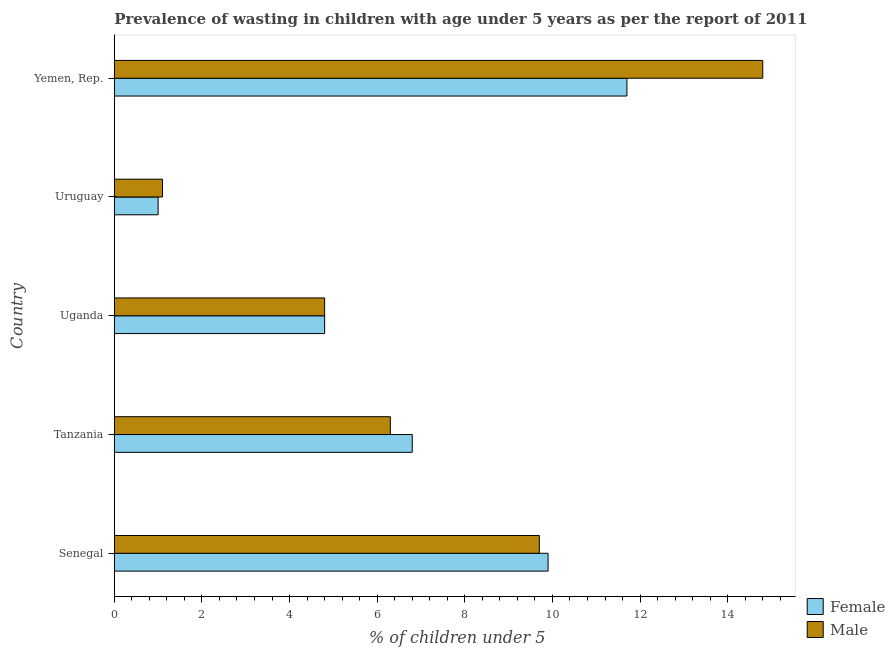How many different coloured bars are there?
Your response must be concise. 2. What is the label of the 3rd group of bars from the top?
Your response must be concise. Uganda. In how many cases, is the number of bars for a given country not equal to the number of legend labels?
Provide a short and direct response. 0. What is the percentage of undernourished female children in Yemen, Rep.?
Offer a terse response. 11.7. Across all countries, what is the maximum percentage of undernourished male children?
Make the answer very short. 14.8. Across all countries, what is the minimum percentage of undernourished male children?
Provide a short and direct response. 1.1. In which country was the percentage of undernourished male children maximum?
Give a very brief answer. Yemen, Rep. In which country was the percentage of undernourished male children minimum?
Keep it short and to the point. Uruguay. What is the total percentage of undernourished female children in the graph?
Offer a very short reply. 34.2. What is the difference between the percentage of undernourished male children in Yemen, Rep. and the percentage of undernourished female children in Uruguay?
Your answer should be very brief. 13.8. What is the average percentage of undernourished male children per country?
Your response must be concise. 7.34. In how many countries, is the percentage of undernourished male children greater than 6.8 %?
Offer a very short reply. 2. What is the ratio of the percentage of undernourished female children in Senegal to that in Uganda?
Ensure brevity in your answer.  2.06. What is the difference between the highest and the second highest percentage of undernourished male children?
Make the answer very short. 5.1. What is the difference between the highest and the lowest percentage of undernourished female children?
Give a very brief answer. 10.7. Is the sum of the percentage of undernourished female children in Uruguay and Yemen, Rep. greater than the maximum percentage of undernourished male children across all countries?
Provide a succinct answer. No. What does the 2nd bar from the top in Senegal represents?
Give a very brief answer. Female. What does the 2nd bar from the bottom in Uganda represents?
Ensure brevity in your answer.  Male. How many legend labels are there?
Offer a terse response. 2. What is the title of the graph?
Keep it short and to the point. Prevalence of wasting in children with age under 5 years as per the report of 2011. Does "Private consumption" appear as one of the legend labels in the graph?
Give a very brief answer. No. What is the label or title of the X-axis?
Keep it short and to the point.  % of children under 5. What is the label or title of the Y-axis?
Provide a short and direct response. Country. What is the  % of children under 5 of Female in Senegal?
Keep it short and to the point. 9.9. What is the  % of children under 5 of Male in Senegal?
Offer a very short reply. 9.7. What is the  % of children under 5 of Female in Tanzania?
Your answer should be compact. 6.8. What is the  % of children under 5 in Male in Tanzania?
Offer a terse response. 6.3. What is the  % of children under 5 of Female in Uganda?
Your answer should be compact. 4.8. What is the  % of children under 5 of Male in Uganda?
Your answer should be very brief. 4.8. What is the  % of children under 5 of Female in Uruguay?
Give a very brief answer. 1. What is the  % of children under 5 in Male in Uruguay?
Provide a succinct answer. 1.1. What is the  % of children under 5 of Female in Yemen, Rep.?
Ensure brevity in your answer.  11.7. What is the  % of children under 5 in Male in Yemen, Rep.?
Ensure brevity in your answer.  14.8. Across all countries, what is the maximum  % of children under 5 of Female?
Your answer should be compact. 11.7. Across all countries, what is the maximum  % of children under 5 in Male?
Offer a terse response. 14.8. Across all countries, what is the minimum  % of children under 5 in Male?
Your answer should be very brief. 1.1. What is the total  % of children under 5 in Female in the graph?
Provide a short and direct response. 34.2. What is the total  % of children under 5 of Male in the graph?
Ensure brevity in your answer.  36.7. What is the difference between the  % of children under 5 in Female in Senegal and that in Uganda?
Keep it short and to the point. 5.1. What is the difference between the  % of children under 5 of Male in Senegal and that in Uruguay?
Give a very brief answer. 8.6. What is the difference between the  % of children under 5 of Female in Senegal and that in Yemen, Rep.?
Provide a short and direct response. -1.8. What is the difference between the  % of children under 5 in Male in Senegal and that in Yemen, Rep.?
Provide a short and direct response. -5.1. What is the difference between the  % of children under 5 in Male in Tanzania and that in Uganda?
Your answer should be very brief. 1.5. What is the difference between the  % of children under 5 in Female in Tanzania and that in Uruguay?
Your response must be concise. 5.8. What is the difference between the  % of children under 5 of Female in Uganda and that in Uruguay?
Your answer should be very brief. 3.8. What is the difference between the  % of children under 5 of Male in Uganda and that in Uruguay?
Give a very brief answer. 3.7. What is the difference between the  % of children under 5 of Female in Uruguay and that in Yemen, Rep.?
Keep it short and to the point. -10.7. What is the difference between the  % of children under 5 of Male in Uruguay and that in Yemen, Rep.?
Offer a very short reply. -13.7. What is the difference between the  % of children under 5 of Female in Uganda and the  % of children under 5 of Male in Uruguay?
Your answer should be very brief. 3.7. What is the difference between the  % of children under 5 of Female in Uganda and the  % of children under 5 of Male in Yemen, Rep.?
Provide a short and direct response. -10. What is the average  % of children under 5 in Female per country?
Ensure brevity in your answer.  6.84. What is the average  % of children under 5 in Male per country?
Your answer should be compact. 7.34. What is the difference between the  % of children under 5 of Female and  % of children under 5 of Male in Tanzania?
Your response must be concise. 0.5. What is the difference between the  % of children under 5 in Female and  % of children under 5 in Male in Yemen, Rep.?
Provide a short and direct response. -3.1. What is the ratio of the  % of children under 5 of Female in Senegal to that in Tanzania?
Your answer should be compact. 1.46. What is the ratio of the  % of children under 5 in Male in Senegal to that in Tanzania?
Provide a short and direct response. 1.54. What is the ratio of the  % of children under 5 of Female in Senegal to that in Uganda?
Provide a short and direct response. 2.06. What is the ratio of the  % of children under 5 in Male in Senegal to that in Uganda?
Provide a short and direct response. 2.02. What is the ratio of the  % of children under 5 of Female in Senegal to that in Uruguay?
Keep it short and to the point. 9.9. What is the ratio of the  % of children under 5 in Male in Senegal to that in Uruguay?
Ensure brevity in your answer.  8.82. What is the ratio of the  % of children under 5 in Female in Senegal to that in Yemen, Rep.?
Provide a succinct answer. 0.85. What is the ratio of the  % of children under 5 in Male in Senegal to that in Yemen, Rep.?
Provide a succinct answer. 0.66. What is the ratio of the  % of children under 5 of Female in Tanzania to that in Uganda?
Your response must be concise. 1.42. What is the ratio of the  % of children under 5 of Male in Tanzania to that in Uganda?
Your response must be concise. 1.31. What is the ratio of the  % of children under 5 in Male in Tanzania to that in Uruguay?
Offer a very short reply. 5.73. What is the ratio of the  % of children under 5 of Female in Tanzania to that in Yemen, Rep.?
Ensure brevity in your answer.  0.58. What is the ratio of the  % of children under 5 of Male in Tanzania to that in Yemen, Rep.?
Your answer should be very brief. 0.43. What is the ratio of the  % of children under 5 in Female in Uganda to that in Uruguay?
Offer a terse response. 4.8. What is the ratio of the  % of children under 5 in Male in Uganda to that in Uruguay?
Give a very brief answer. 4.36. What is the ratio of the  % of children under 5 of Female in Uganda to that in Yemen, Rep.?
Keep it short and to the point. 0.41. What is the ratio of the  % of children under 5 in Male in Uganda to that in Yemen, Rep.?
Your response must be concise. 0.32. What is the ratio of the  % of children under 5 in Female in Uruguay to that in Yemen, Rep.?
Keep it short and to the point. 0.09. What is the ratio of the  % of children under 5 of Male in Uruguay to that in Yemen, Rep.?
Ensure brevity in your answer.  0.07. What is the difference between the highest and the second highest  % of children under 5 in Male?
Offer a terse response. 5.1. 